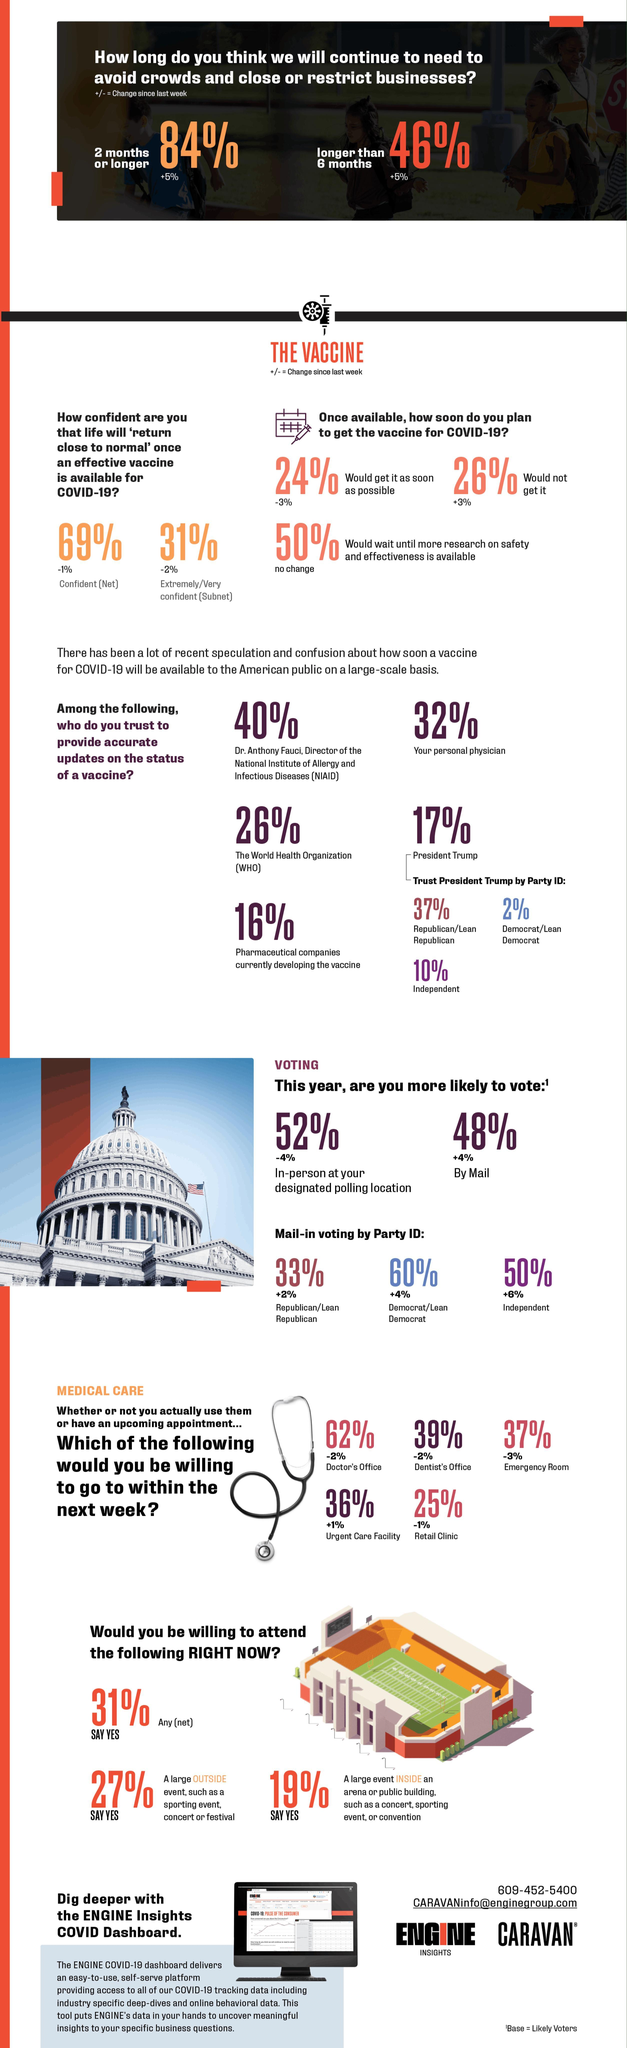What percent of Democrats are planning to vote by mail?
Answer the question with a short phrase. 60% How many of the people trust President Trump regarding updates on COVID-19 vaccine? 17% How many of the Republicans trust President Trump regarding updates on COVID-19 vaccine? 37% How are 52% of people likely to vote? in-person Whom does 26% of people trust regarding status of COVID-19 vaccine? WHO Whom does most people trust regarding updates on COVID-19 vaccine status? Dr. Anthony Fauci How many of the people would wait for research about vaccine effectiveness before getting it? 50% What percent of people showed willingness to attend large indoor event like a concert? 19% What percent of people are likely to vote by mail? 48% How many people are confident life will return to normal when vaccine is available? 69% 